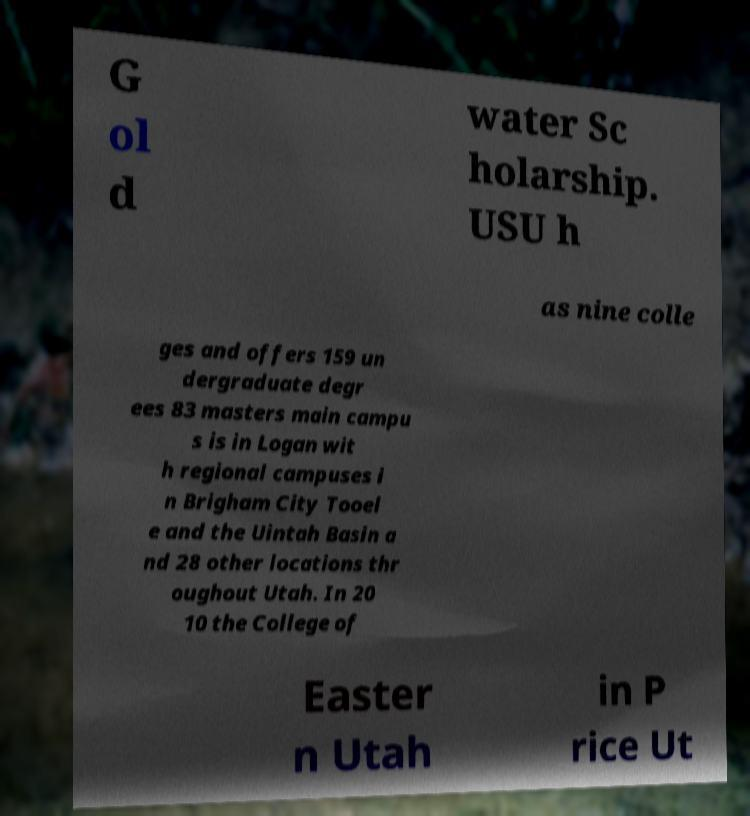Please identify and transcribe the text found in this image. G ol d water Sc holarship. USU h as nine colle ges and offers 159 un dergraduate degr ees 83 masters main campu s is in Logan wit h regional campuses i n Brigham City Tooel e and the Uintah Basin a nd 28 other locations thr oughout Utah. In 20 10 the College of Easter n Utah in P rice Ut 